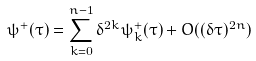Convert formula to latex. <formula><loc_0><loc_0><loc_500><loc_500>\psi ^ { + } ( \tau ) = \sum _ { k = 0 } ^ { n - 1 } \delta ^ { 2 k } \psi ^ { + } _ { k } ( \tau ) + O ( ( \delta \tau ) ^ { 2 n } )</formula> 